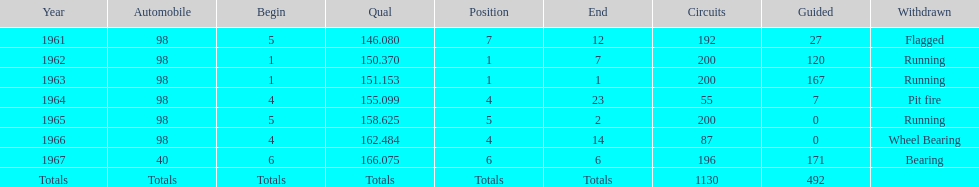In which years did he lead the race the least? 1965, 1966. 